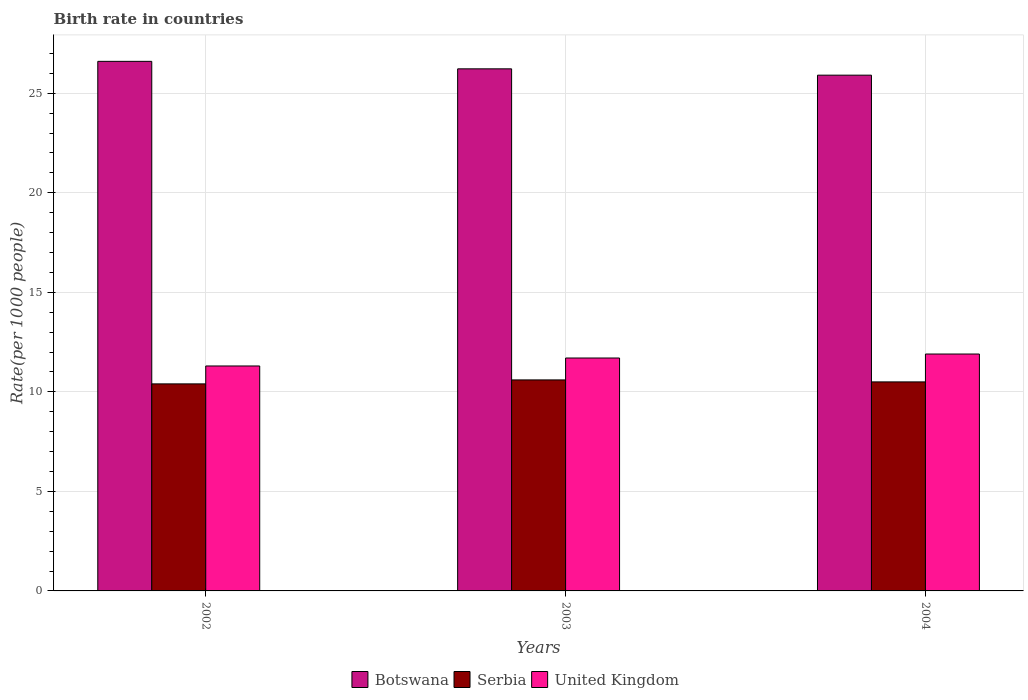How many groups of bars are there?
Keep it short and to the point. 3. Are the number of bars per tick equal to the number of legend labels?
Ensure brevity in your answer.  Yes. Are the number of bars on each tick of the X-axis equal?
Keep it short and to the point. Yes. How many bars are there on the 3rd tick from the right?
Your response must be concise. 3. What is the label of the 2nd group of bars from the left?
Give a very brief answer. 2003. In how many cases, is the number of bars for a given year not equal to the number of legend labels?
Offer a terse response. 0. Across all years, what is the maximum birth rate in United Kingdom?
Your answer should be very brief. 11.9. Across all years, what is the minimum birth rate in Serbia?
Offer a very short reply. 10.4. In which year was the birth rate in Botswana maximum?
Provide a succinct answer. 2002. What is the total birth rate in Botswana in the graph?
Offer a terse response. 78.74. What is the difference between the birth rate in Serbia in 2002 and that in 2004?
Make the answer very short. -0.1. What is the difference between the birth rate in Serbia in 2003 and the birth rate in Botswana in 2004?
Provide a short and direct response. -15.31. In the year 2002, what is the difference between the birth rate in Serbia and birth rate in Botswana?
Provide a short and direct response. -16.2. In how many years, is the birth rate in Botswana greater than 20?
Give a very brief answer. 3. What is the ratio of the birth rate in United Kingdom in 2002 to that in 2003?
Provide a succinct answer. 0.97. What is the difference between the highest and the second highest birth rate in United Kingdom?
Your answer should be compact. 0.2. What is the difference between the highest and the lowest birth rate in United Kingdom?
Ensure brevity in your answer.  0.6. In how many years, is the birth rate in Botswana greater than the average birth rate in Botswana taken over all years?
Your answer should be very brief. 1. What does the 1st bar from the left in 2003 represents?
Keep it short and to the point. Botswana. Is it the case that in every year, the sum of the birth rate in Botswana and birth rate in Serbia is greater than the birth rate in United Kingdom?
Your answer should be compact. Yes. How many bars are there?
Provide a succinct answer. 9. Are all the bars in the graph horizontal?
Make the answer very short. No. How many years are there in the graph?
Offer a very short reply. 3. Where does the legend appear in the graph?
Keep it short and to the point. Bottom center. What is the title of the graph?
Make the answer very short. Birth rate in countries. What is the label or title of the Y-axis?
Offer a very short reply. Rate(per 1000 people). What is the Rate(per 1000 people) in Botswana in 2002?
Provide a short and direct response. 26.6. What is the Rate(per 1000 people) in United Kingdom in 2002?
Your response must be concise. 11.3. What is the Rate(per 1000 people) of Botswana in 2003?
Offer a terse response. 26.23. What is the Rate(per 1000 people) of Botswana in 2004?
Give a very brief answer. 25.91. What is the Rate(per 1000 people) in Serbia in 2004?
Your response must be concise. 10.5. Across all years, what is the maximum Rate(per 1000 people) in Botswana?
Give a very brief answer. 26.6. Across all years, what is the minimum Rate(per 1000 people) of Botswana?
Offer a terse response. 25.91. What is the total Rate(per 1000 people) of Botswana in the graph?
Make the answer very short. 78.74. What is the total Rate(per 1000 people) of Serbia in the graph?
Provide a succinct answer. 31.5. What is the total Rate(per 1000 people) in United Kingdom in the graph?
Provide a short and direct response. 34.9. What is the difference between the Rate(per 1000 people) of Botswana in 2002 and that in 2003?
Give a very brief answer. 0.38. What is the difference between the Rate(per 1000 people) of Botswana in 2002 and that in 2004?
Ensure brevity in your answer.  0.69. What is the difference between the Rate(per 1000 people) in Serbia in 2002 and that in 2004?
Offer a terse response. -0.1. What is the difference between the Rate(per 1000 people) in United Kingdom in 2002 and that in 2004?
Your response must be concise. -0.6. What is the difference between the Rate(per 1000 people) in Botswana in 2003 and that in 2004?
Your answer should be very brief. 0.32. What is the difference between the Rate(per 1000 people) of Botswana in 2002 and the Rate(per 1000 people) of Serbia in 2003?
Offer a very short reply. 16. What is the difference between the Rate(per 1000 people) of Botswana in 2002 and the Rate(per 1000 people) of United Kingdom in 2003?
Make the answer very short. 14.9. What is the difference between the Rate(per 1000 people) of Botswana in 2002 and the Rate(per 1000 people) of Serbia in 2004?
Make the answer very short. 16.1. What is the difference between the Rate(per 1000 people) in Botswana in 2002 and the Rate(per 1000 people) in United Kingdom in 2004?
Your answer should be compact. 14.7. What is the difference between the Rate(per 1000 people) of Botswana in 2003 and the Rate(per 1000 people) of Serbia in 2004?
Provide a succinct answer. 15.73. What is the difference between the Rate(per 1000 people) of Botswana in 2003 and the Rate(per 1000 people) of United Kingdom in 2004?
Provide a short and direct response. 14.33. What is the difference between the Rate(per 1000 people) of Serbia in 2003 and the Rate(per 1000 people) of United Kingdom in 2004?
Your answer should be very brief. -1.3. What is the average Rate(per 1000 people) in Botswana per year?
Keep it short and to the point. 26.25. What is the average Rate(per 1000 people) of Serbia per year?
Your answer should be compact. 10.5. What is the average Rate(per 1000 people) of United Kingdom per year?
Make the answer very short. 11.63. In the year 2002, what is the difference between the Rate(per 1000 people) of Botswana and Rate(per 1000 people) of Serbia?
Give a very brief answer. 16.2. In the year 2002, what is the difference between the Rate(per 1000 people) in Botswana and Rate(per 1000 people) in United Kingdom?
Your answer should be very brief. 15.3. In the year 2002, what is the difference between the Rate(per 1000 people) in Serbia and Rate(per 1000 people) in United Kingdom?
Your response must be concise. -0.9. In the year 2003, what is the difference between the Rate(per 1000 people) of Botswana and Rate(per 1000 people) of Serbia?
Offer a terse response. 15.63. In the year 2003, what is the difference between the Rate(per 1000 people) in Botswana and Rate(per 1000 people) in United Kingdom?
Provide a succinct answer. 14.53. In the year 2003, what is the difference between the Rate(per 1000 people) of Serbia and Rate(per 1000 people) of United Kingdom?
Your response must be concise. -1.1. In the year 2004, what is the difference between the Rate(per 1000 people) in Botswana and Rate(per 1000 people) in Serbia?
Offer a terse response. 15.41. In the year 2004, what is the difference between the Rate(per 1000 people) in Botswana and Rate(per 1000 people) in United Kingdom?
Your response must be concise. 14.01. What is the ratio of the Rate(per 1000 people) of Botswana in 2002 to that in 2003?
Keep it short and to the point. 1.01. What is the ratio of the Rate(per 1000 people) of Serbia in 2002 to that in 2003?
Offer a very short reply. 0.98. What is the ratio of the Rate(per 1000 people) of United Kingdom in 2002 to that in 2003?
Provide a short and direct response. 0.97. What is the ratio of the Rate(per 1000 people) in Botswana in 2002 to that in 2004?
Give a very brief answer. 1.03. What is the ratio of the Rate(per 1000 people) of United Kingdom in 2002 to that in 2004?
Keep it short and to the point. 0.95. What is the ratio of the Rate(per 1000 people) of Botswana in 2003 to that in 2004?
Your answer should be very brief. 1.01. What is the ratio of the Rate(per 1000 people) in Serbia in 2003 to that in 2004?
Provide a short and direct response. 1.01. What is the ratio of the Rate(per 1000 people) of United Kingdom in 2003 to that in 2004?
Keep it short and to the point. 0.98. What is the difference between the highest and the second highest Rate(per 1000 people) in Botswana?
Provide a succinct answer. 0.38. What is the difference between the highest and the second highest Rate(per 1000 people) of Serbia?
Your response must be concise. 0.1. What is the difference between the highest and the lowest Rate(per 1000 people) of Botswana?
Keep it short and to the point. 0.69. What is the difference between the highest and the lowest Rate(per 1000 people) of United Kingdom?
Make the answer very short. 0.6. 